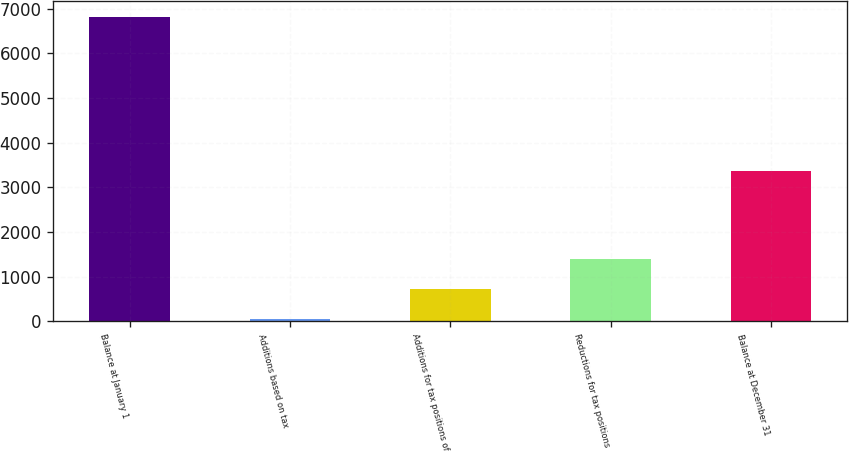<chart> <loc_0><loc_0><loc_500><loc_500><bar_chart><fcel>Balance at January 1<fcel>Additions based on tax<fcel>Additions for tax positions of<fcel>Reductions for tax positions<fcel>Balance at December 31<nl><fcel>6824<fcel>50<fcel>727.4<fcel>1404.8<fcel>3369<nl></chart> 